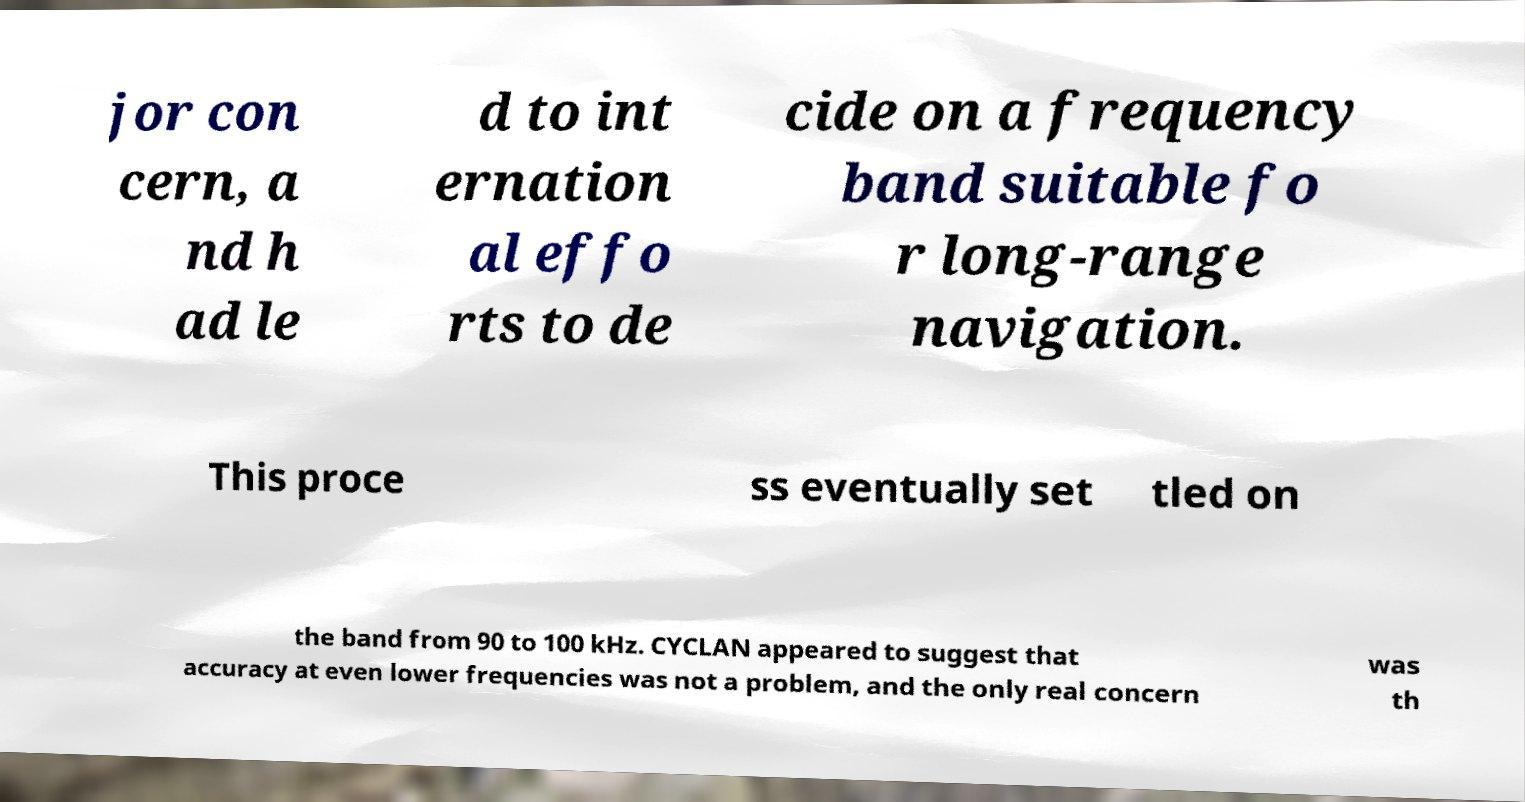Could you assist in decoding the text presented in this image and type it out clearly? jor con cern, a nd h ad le d to int ernation al effo rts to de cide on a frequency band suitable fo r long-range navigation. This proce ss eventually set tled on the band from 90 to 100 kHz. CYCLAN appeared to suggest that accuracy at even lower frequencies was not a problem, and the only real concern was th 